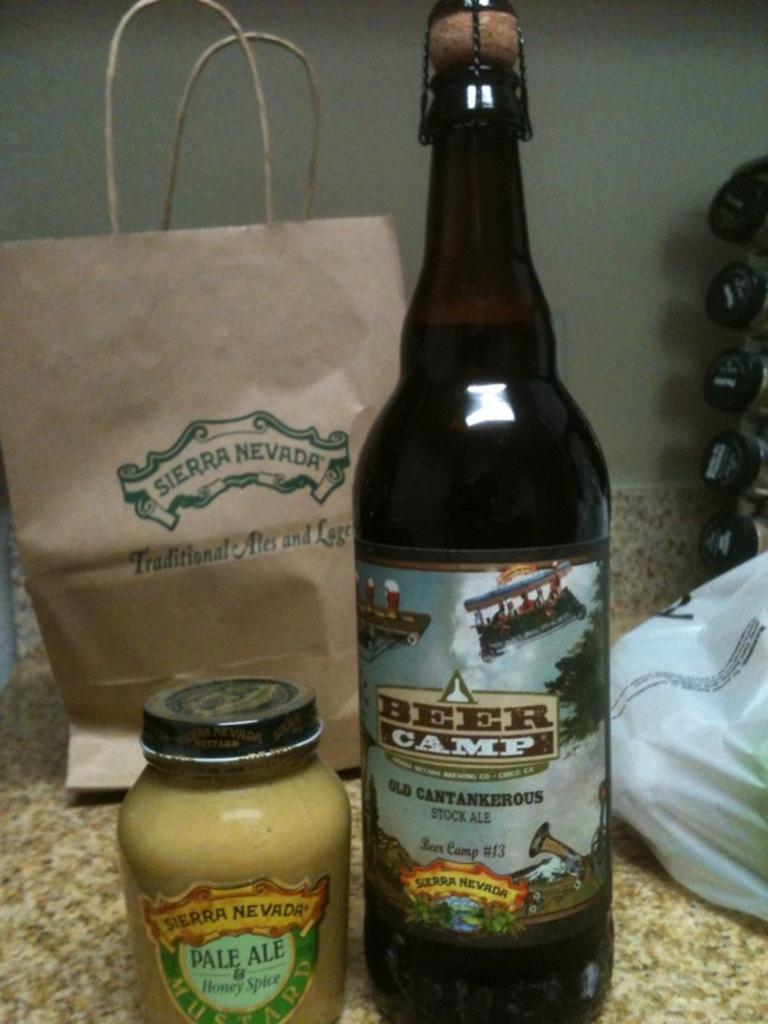<image>
Give a short and clear explanation of the subsequent image. A bottle of Beer Camp Old Cantankerous beer is next to a jar of Honey spice. 